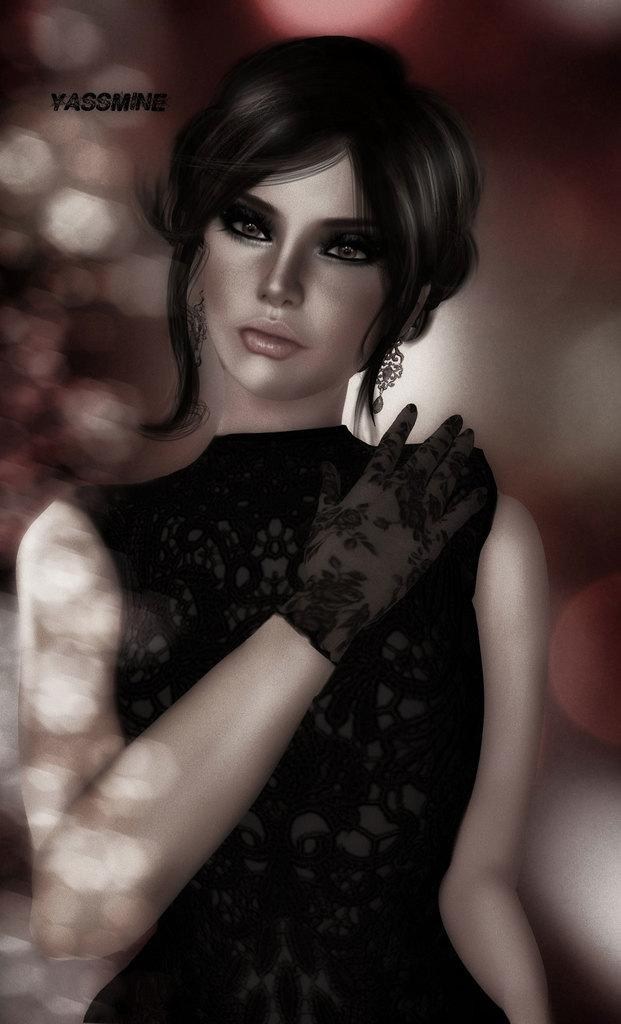What is the main subject of the image? The main subject of the image is a woman standing in the middle of the image. Can you describe any text that is visible in the image? Yes, there is some text at the top of the image. Reasoning: Let'g: Let's think step by step in order to produce the conversation. We start by identifying the main subject of the image, which is the woman standing in the middle. Then, we acknowledge the presence of text in the image, which is mentioned as a fact. We avoid asking questions that cannot be answered definitively based on the provided facts. Absurd Question/Answer: What type of shoes is the woman wearing in the image? There is no information about the woman's shoes in the image, so we cannot determine what type she is wearing. What type of glass is the woman holding in the image? There is no glass present in the image, so we cannot determine what type she might be holding. 